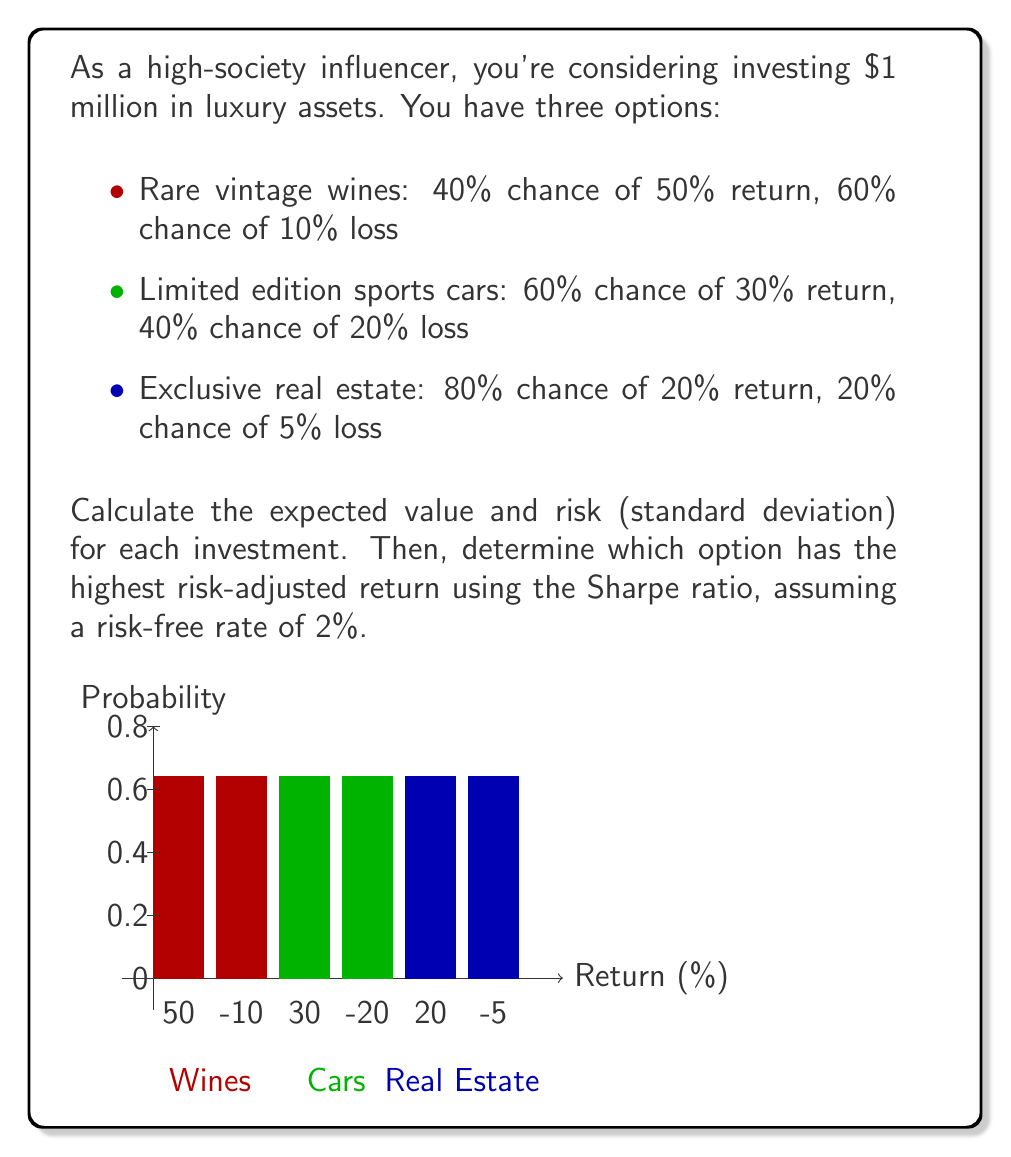Teach me how to tackle this problem. Let's solve this step-by-step:

1. Calculate the expected return for each investment:

   a) Wines: $E_w = 0.4 \cdot 50\% + 0.6 \cdot (-10\%) = 14\%$
   b) Cars: $E_c = 0.6 \cdot 30\% + 0.4 \cdot (-20\%) = 10\%$
   c) Real Estate: $E_r = 0.8 \cdot 20\% + 0.2 \cdot (-5\%) = 15\%$

2. Calculate the variance for each investment:

   a) Wines: $\sigma_w^2 = 0.4 \cdot (50\% - 14\%)^2 + 0.6 \cdot (-10\% - 14\%)^2 = 0.0900$
   b) Cars: $\sigma_c^2 = 0.6 \cdot (30\% - 10\%)^2 + 0.4 \cdot (-20\% - 10\%)^2 = 0.0600$
   c) Real Estate: $\sigma_r^2 = 0.8 \cdot (20\% - 15\%)^2 + 0.2 \cdot (-5\% - 15\%)^2 = 0.0125$

3. Calculate the standard deviation (risk) for each investment:

   a) Wines: $\sigma_w = \sqrt{0.0900} = 30\%$
   b) Cars: $\sigma_c = \sqrt{0.0600} = 24.49\%$
   c) Real Estate: $\sigma_r = \sqrt{0.0125} = 11.18\%$

4. Calculate the Sharpe ratio for each investment:

   Sharpe ratio = $\frac{E_i - R_f}{\sigma_i}$, where $E_i$ is the expected return, $R_f$ is the risk-free rate, and $\sigma_i$ is the standard deviation.

   a) Wines: $S_w = \frac{14\% - 2\%}{30\%} = 0.40$
   b) Cars: $S_c = \frac{10\% - 2\%}{24.49\%} = 0.33$
   c) Real Estate: $S_r = \frac{15\% - 2\%}{11.18\%} = 1.16$

5. Compare the Sharpe ratios:

   Real Estate has the highest Sharpe ratio at 1.16, followed by Wines at 0.40, and Cars at 0.33.
Answer: Real Estate (Sharpe ratio: 1.16) 